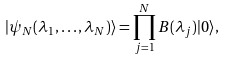Convert formula to latex. <formula><loc_0><loc_0><loc_500><loc_500>| \psi _ { N } ( \lambda _ { 1 } , \dots , \lambda _ { N } ) \rangle = \prod _ { j = 1 } ^ { N } B ( \lambda _ { j } ) | 0 \rangle ,</formula> 